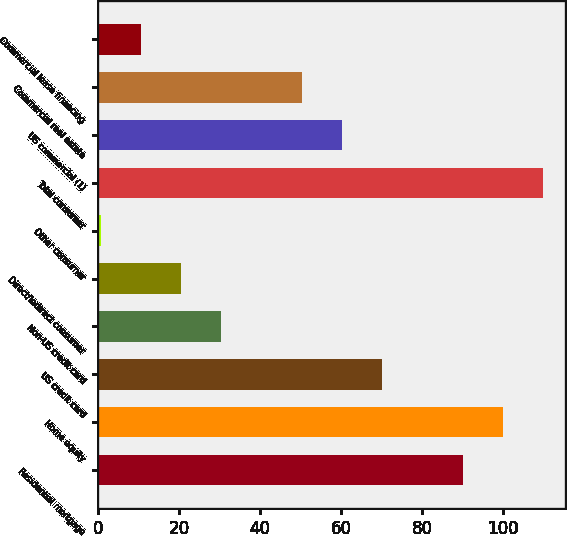<chart> <loc_0><loc_0><loc_500><loc_500><bar_chart><fcel>Residential mortgage<fcel>Home equity<fcel>US credit card<fcel>Non-US credit card<fcel>Direct/Indirect consumer<fcel>Other consumer<fcel>Total consumer<fcel>US commercial (1)<fcel>Commercial real estate<fcel>Commercial lease financing<nl><fcel>90.04<fcel>99.98<fcel>70.16<fcel>30.4<fcel>20.46<fcel>0.58<fcel>109.92<fcel>60.22<fcel>50.28<fcel>10.52<nl></chart> 